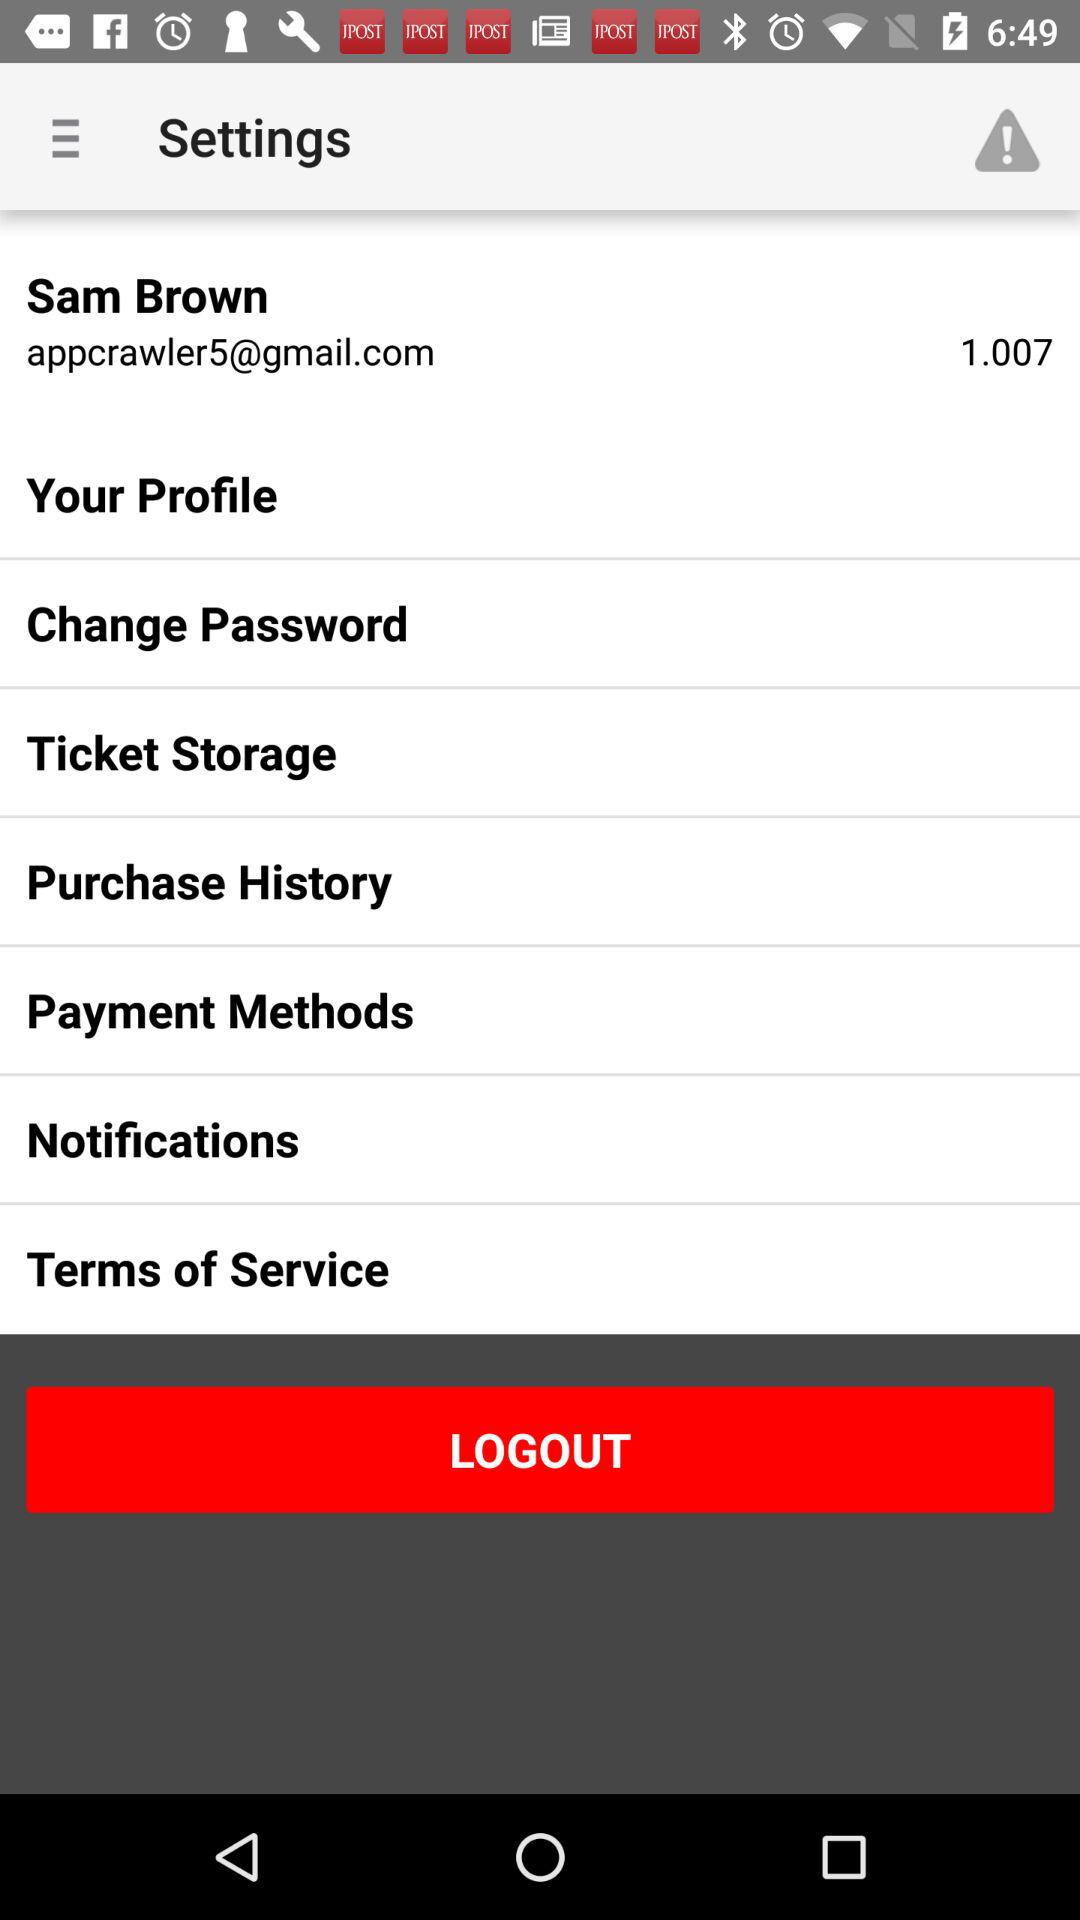What is the given decimal number on the screen? The given decimal number is 1.007. 